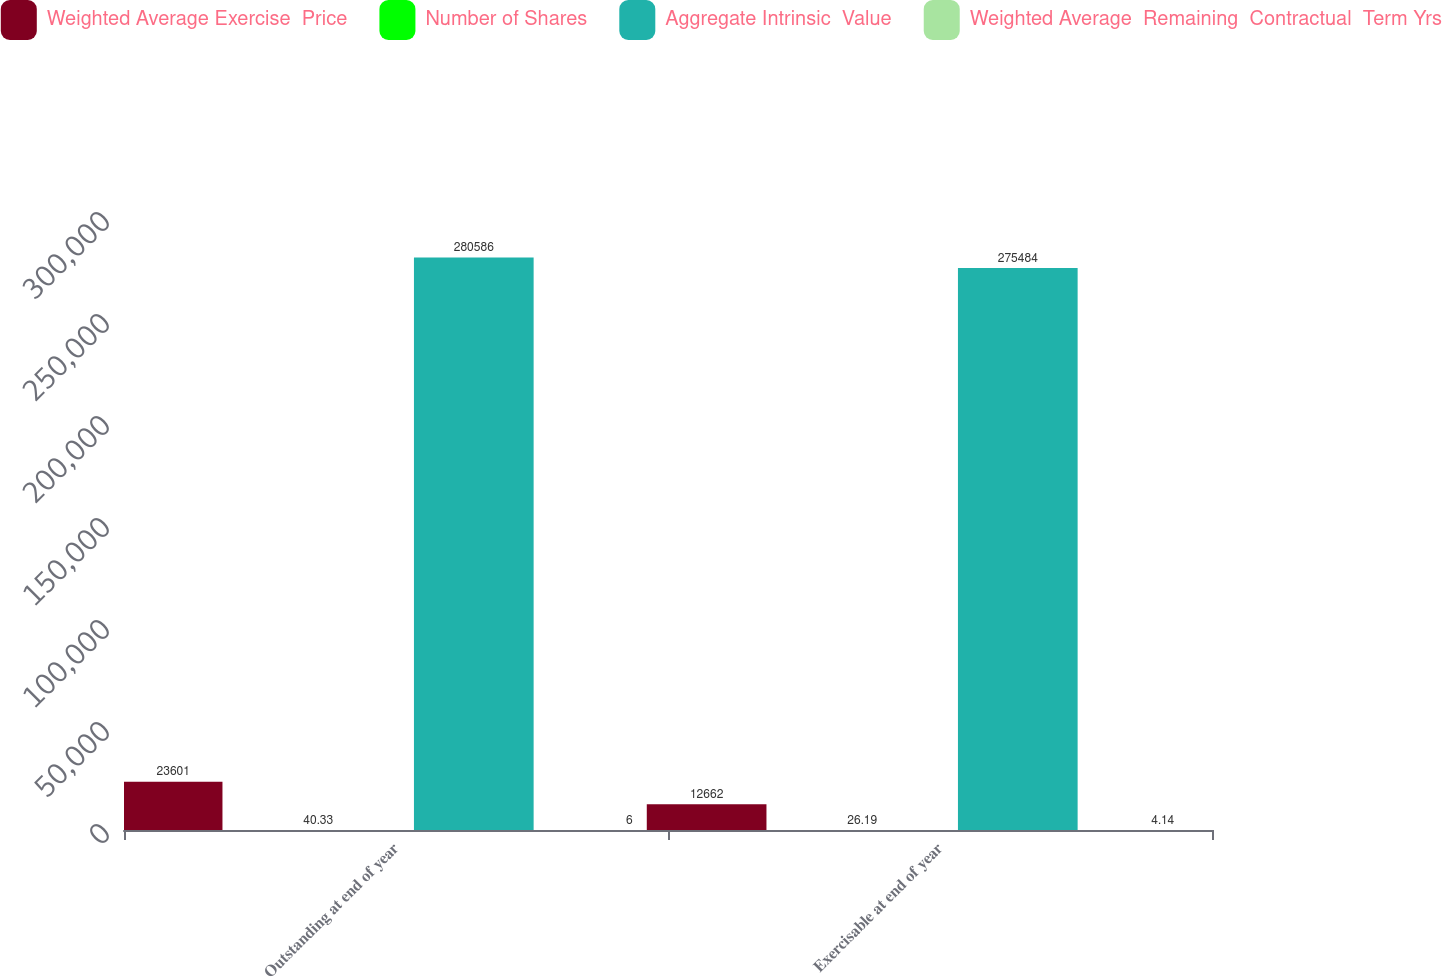<chart> <loc_0><loc_0><loc_500><loc_500><stacked_bar_chart><ecel><fcel>Outstanding at end of year<fcel>Exercisable at end of year<nl><fcel>Weighted Average Exercise  Price<fcel>23601<fcel>12662<nl><fcel>Number of Shares<fcel>40.33<fcel>26.19<nl><fcel>Aggregate Intrinsic  Value<fcel>280586<fcel>275484<nl><fcel>Weighted Average  Remaining  Contractual  Term Yrs<fcel>6<fcel>4.14<nl></chart> 